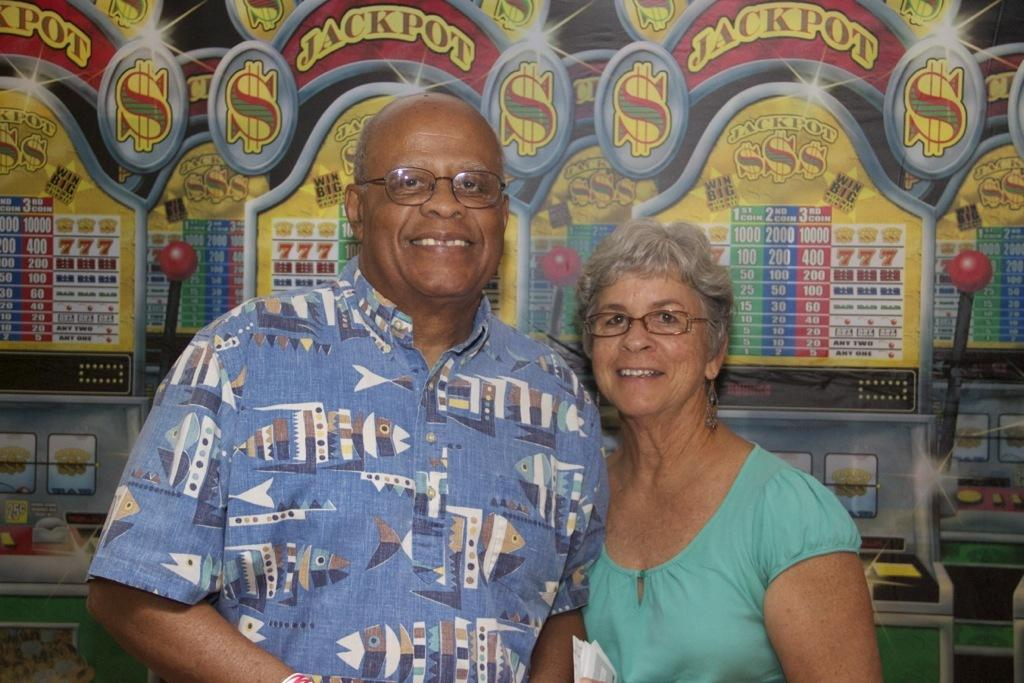How many people are present in the image? There are two persons in the image. What can be seen in the background of the image? Gaming consoles are visible in the background of the image. What type of bomb can be seen in the image? There is no bomb present in the image; it features two persons and gaming consoles in the background. 